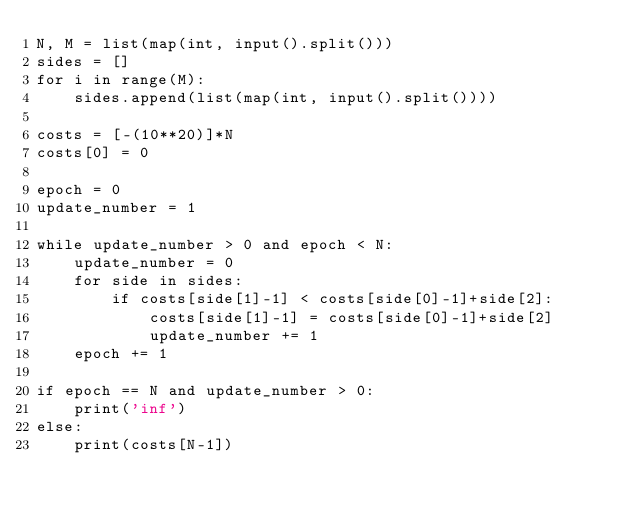<code> <loc_0><loc_0><loc_500><loc_500><_Python_>N, M = list(map(int, input().split()))
sides = []
for i in range(M):
    sides.append(list(map(int, input().split())))

costs = [-(10**20)]*N
costs[0] = 0

epoch = 0
update_number = 1

while update_number > 0 and epoch < N:
    update_number = 0
    for side in sides:
        if costs[side[1]-1] < costs[side[0]-1]+side[2]:
            costs[side[1]-1] = costs[side[0]-1]+side[2]
            update_number += 1
    epoch += 1

if epoch == N and update_number > 0:
    print('inf')
else:
    print(costs[N-1])</code> 